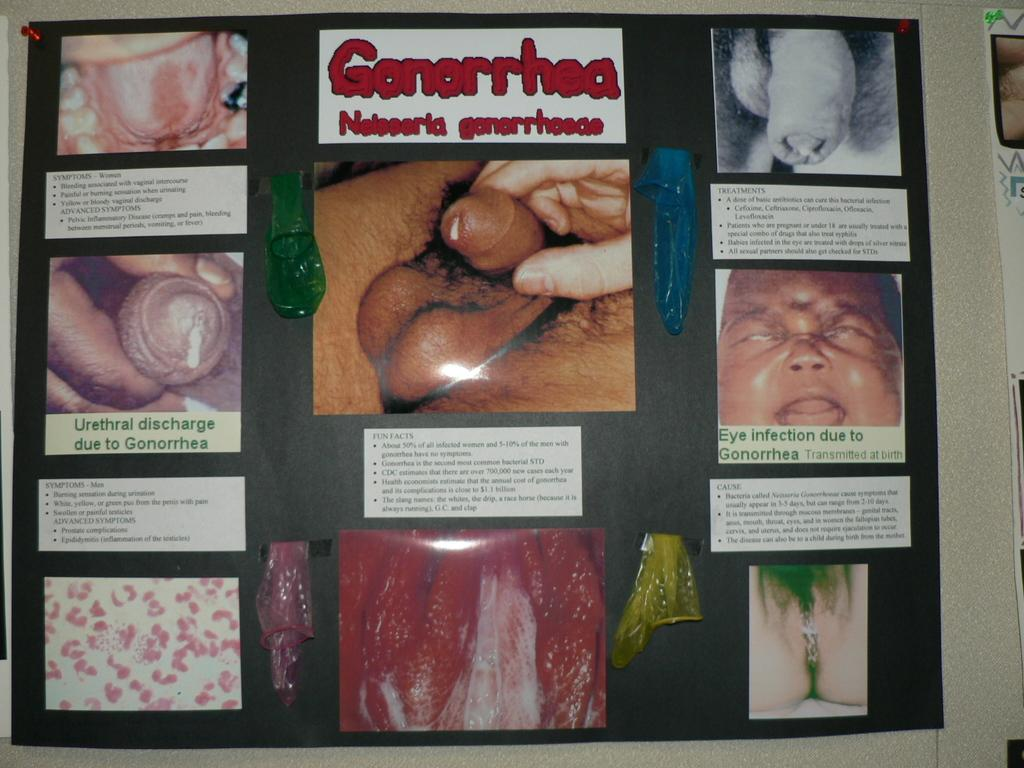What is attached to the black surface in the image? There are papers attached to a black surface in the image. What can be seen on the papers? There is writing visible on the image. What is the main subject of the image? A baby's face is present in the image. What parts of the baby's body can be seen in the image? Some of the baby's body parts are visible in the image. What color is the paint on the baby's face in the image? There is no paint visible on the baby's face in the image. Can you see any ants crawling on the baby's face in the image? There are no ants present in the image. 